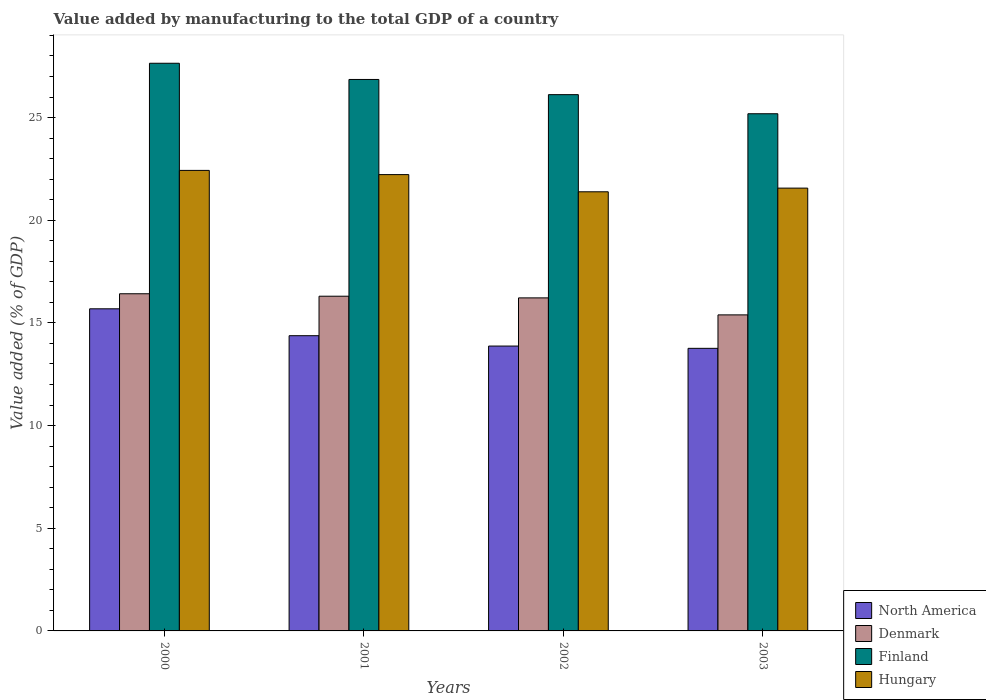How many different coloured bars are there?
Keep it short and to the point. 4. How many groups of bars are there?
Provide a short and direct response. 4. Are the number of bars on each tick of the X-axis equal?
Make the answer very short. Yes. How many bars are there on the 4th tick from the right?
Offer a terse response. 4. What is the label of the 3rd group of bars from the left?
Provide a succinct answer. 2002. What is the value added by manufacturing to the total GDP in North America in 2002?
Your answer should be compact. 13.87. Across all years, what is the maximum value added by manufacturing to the total GDP in Finland?
Your answer should be compact. 27.64. Across all years, what is the minimum value added by manufacturing to the total GDP in Denmark?
Your answer should be very brief. 15.39. In which year was the value added by manufacturing to the total GDP in Finland maximum?
Ensure brevity in your answer.  2000. In which year was the value added by manufacturing to the total GDP in Denmark minimum?
Keep it short and to the point. 2003. What is the total value added by manufacturing to the total GDP in Finland in the graph?
Your response must be concise. 105.8. What is the difference between the value added by manufacturing to the total GDP in North America in 2002 and that in 2003?
Give a very brief answer. 0.11. What is the difference between the value added by manufacturing to the total GDP in Finland in 2000 and the value added by manufacturing to the total GDP in North America in 2003?
Give a very brief answer. 13.88. What is the average value added by manufacturing to the total GDP in Denmark per year?
Offer a very short reply. 16.08. In the year 2003, what is the difference between the value added by manufacturing to the total GDP in Denmark and value added by manufacturing to the total GDP in North America?
Give a very brief answer. 1.63. What is the ratio of the value added by manufacturing to the total GDP in Denmark in 2001 to that in 2003?
Offer a very short reply. 1.06. What is the difference between the highest and the second highest value added by manufacturing to the total GDP in Hungary?
Make the answer very short. 0.2. What is the difference between the highest and the lowest value added by manufacturing to the total GDP in North America?
Keep it short and to the point. 1.92. In how many years, is the value added by manufacturing to the total GDP in Finland greater than the average value added by manufacturing to the total GDP in Finland taken over all years?
Give a very brief answer. 2. Is the sum of the value added by manufacturing to the total GDP in Denmark in 2000 and 2003 greater than the maximum value added by manufacturing to the total GDP in Finland across all years?
Offer a very short reply. Yes. What does the 4th bar from the right in 2003 represents?
Offer a terse response. North America. Is it the case that in every year, the sum of the value added by manufacturing to the total GDP in North America and value added by manufacturing to the total GDP in Denmark is greater than the value added by manufacturing to the total GDP in Hungary?
Ensure brevity in your answer.  Yes. How many bars are there?
Ensure brevity in your answer.  16. How many years are there in the graph?
Provide a short and direct response. 4. What is the difference between two consecutive major ticks on the Y-axis?
Your answer should be very brief. 5. Are the values on the major ticks of Y-axis written in scientific E-notation?
Offer a very short reply. No. Where does the legend appear in the graph?
Ensure brevity in your answer.  Bottom right. How are the legend labels stacked?
Provide a short and direct response. Vertical. What is the title of the graph?
Your response must be concise. Value added by manufacturing to the total GDP of a country. What is the label or title of the Y-axis?
Ensure brevity in your answer.  Value added (% of GDP). What is the Value added (% of GDP) of North America in 2000?
Your response must be concise. 15.69. What is the Value added (% of GDP) in Denmark in 2000?
Provide a short and direct response. 16.42. What is the Value added (% of GDP) in Finland in 2000?
Provide a short and direct response. 27.64. What is the Value added (% of GDP) of Hungary in 2000?
Provide a succinct answer. 22.43. What is the Value added (% of GDP) in North America in 2001?
Provide a short and direct response. 14.38. What is the Value added (% of GDP) of Denmark in 2001?
Make the answer very short. 16.3. What is the Value added (% of GDP) in Finland in 2001?
Your answer should be very brief. 26.85. What is the Value added (% of GDP) in Hungary in 2001?
Keep it short and to the point. 22.22. What is the Value added (% of GDP) of North America in 2002?
Your answer should be compact. 13.87. What is the Value added (% of GDP) in Denmark in 2002?
Give a very brief answer. 16.22. What is the Value added (% of GDP) of Finland in 2002?
Provide a short and direct response. 26.12. What is the Value added (% of GDP) of Hungary in 2002?
Make the answer very short. 21.38. What is the Value added (% of GDP) of North America in 2003?
Offer a very short reply. 13.76. What is the Value added (% of GDP) of Denmark in 2003?
Ensure brevity in your answer.  15.39. What is the Value added (% of GDP) of Finland in 2003?
Provide a short and direct response. 25.18. What is the Value added (% of GDP) in Hungary in 2003?
Offer a terse response. 21.56. Across all years, what is the maximum Value added (% of GDP) of North America?
Make the answer very short. 15.69. Across all years, what is the maximum Value added (% of GDP) in Denmark?
Ensure brevity in your answer.  16.42. Across all years, what is the maximum Value added (% of GDP) of Finland?
Give a very brief answer. 27.64. Across all years, what is the maximum Value added (% of GDP) in Hungary?
Your answer should be compact. 22.43. Across all years, what is the minimum Value added (% of GDP) of North America?
Your answer should be compact. 13.76. Across all years, what is the minimum Value added (% of GDP) in Denmark?
Offer a very short reply. 15.39. Across all years, what is the minimum Value added (% of GDP) of Finland?
Your answer should be very brief. 25.18. Across all years, what is the minimum Value added (% of GDP) of Hungary?
Provide a succinct answer. 21.38. What is the total Value added (% of GDP) of North America in the graph?
Ensure brevity in your answer.  57.7. What is the total Value added (% of GDP) in Denmark in the graph?
Your answer should be very brief. 64.33. What is the total Value added (% of GDP) in Finland in the graph?
Make the answer very short. 105.8. What is the total Value added (% of GDP) of Hungary in the graph?
Your answer should be very brief. 87.59. What is the difference between the Value added (% of GDP) of North America in 2000 and that in 2001?
Your answer should be compact. 1.31. What is the difference between the Value added (% of GDP) in Denmark in 2000 and that in 2001?
Your answer should be very brief. 0.12. What is the difference between the Value added (% of GDP) in Finland in 2000 and that in 2001?
Give a very brief answer. 0.79. What is the difference between the Value added (% of GDP) in Hungary in 2000 and that in 2001?
Make the answer very short. 0.2. What is the difference between the Value added (% of GDP) of North America in 2000 and that in 2002?
Make the answer very short. 1.81. What is the difference between the Value added (% of GDP) in Denmark in 2000 and that in 2002?
Your response must be concise. 0.2. What is the difference between the Value added (% of GDP) of Finland in 2000 and that in 2002?
Offer a terse response. 1.53. What is the difference between the Value added (% of GDP) of Hungary in 2000 and that in 2002?
Give a very brief answer. 1.04. What is the difference between the Value added (% of GDP) of North America in 2000 and that in 2003?
Provide a short and direct response. 1.92. What is the difference between the Value added (% of GDP) of Denmark in 2000 and that in 2003?
Your answer should be compact. 1.03. What is the difference between the Value added (% of GDP) of Finland in 2000 and that in 2003?
Give a very brief answer. 2.46. What is the difference between the Value added (% of GDP) of Hungary in 2000 and that in 2003?
Your answer should be compact. 0.86. What is the difference between the Value added (% of GDP) in North America in 2001 and that in 2002?
Provide a succinct answer. 0.5. What is the difference between the Value added (% of GDP) in Denmark in 2001 and that in 2002?
Your answer should be compact. 0.08. What is the difference between the Value added (% of GDP) in Finland in 2001 and that in 2002?
Provide a short and direct response. 0.74. What is the difference between the Value added (% of GDP) of Hungary in 2001 and that in 2002?
Your answer should be compact. 0.84. What is the difference between the Value added (% of GDP) of North America in 2001 and that in 2003?
Your response must be concise. 0.62. What is the difference between the Value added (% of GDP) in Denmark in 2001 and that in 2003?
Offer a very short reply. 0.91. What is the difference between the Value added (% of GDP) in Finland in 2001 and that in 2003?
Your response must be concise. 1.67. What is the difference between the Value added (% of GDP) in Hungary in 2001 and that in 2003?
Offer a terse response. 0.66. What is the difference between the Value added (% of GDP) of Denmark in 2002 and that in 2003?
Keep it short and to the point. 0.83. What is the difference between the Value added (% of GDP) in Finland in 2002 and that in 2003?
Offer a terse response. 0.93. What is the difference between the Value added (% of GDP) of Hungary in 2002 and that in 2003?
Keep it short and to the point. -0.18. What is the difference between the Value added (% of GDP) in North America in 2000 and the Value added (% of GDP) in Denmark in 2001?
Your answer should be very brief. -0.61. What is the difference between the Value added (% of GDP) in North America in 2000 and the Value added (% of GDP) in Finland in 2001?
Provide a short and direct response. -11.17. What is the difference between the Value added (% of GDP) in North America in 2000 and the Value added (% of GDP) in Hungary in 2001?
Your answer should be compact. -6.54. What is the difference between the Value added (% of GDP) in Denmark in 2000 and the Value added (% of GDP) in Finland in 2001?
Provide a short and direct response. -10.44. What is the difference between the Value added (% of GDP) of Denmark in 2000 and the Value added (% of GDP) of Hungary in 2001?
Your answer should be very brief. -5.8. What is the difference between the Value added (% of GDP) of Finland in 2000 and the Value added (% of GDP) of Hungary in 2001?
Keep it short and to the point. 5.42. What is the difference between the Value added (% of GDP) of North America in 2000 and the Value added (% of GDP) of Denmark in 2002?
Your answer should be compact. -0.53. What is the difference between the Value added (% of GDP) of North America in 2000 and the Value added (% of GDP) of Finland in 2002?
Offer a terse response. -10.43. What is the difference between the Value added (% of GDP) in North America in 2000 and the Value added (% of GDP) in Hungary in 2002?
Your answer should be very brief. -5.7. What is the difference between the Value added (% of GDP) in Denmark in 2000 and the Value added (% of GDP) in Finland in 2002?
Ensure brevity in your answer.  -9.7. What is the difference between the Value added (% of GDP) in Denmark in 2000 and the Value added (% of GDP) in Hungary in 2002?
Make the answer very short. -4.97. What is the difference between the Value added (% of GDP) in Finland in 2000 and the Value added (% of GDP) in Hungary in 2002?
Your answer should be very brief. 6.26. What is the difference between the Value added (% of GDP) in North America in 2000 and the Value added (% of GDP) in Denmark in 2003?
Provide a succinct answer. 0.3. What is the difference between the Value added (% of GDP) of North America in 2000 and the Value added (% of GDP) of Finland in 2003?
Provide a short and direct response. -9.5. What is the difference between the Value added (% of GDP) in North America in 2000 and the Value added (% of GDP) in Hungary in 2003?
Provide a succinct answer. -5.88. What is the difference between the Value added (% of GDP) of Denmark in 2000 and the Value added (% of GDP) of Finland in 2003?
Your response must be concise. -8.77. What is the difference between the Value added (% of GDP) of Denmark in 2000 and the Value added (% of GDP) of Hungary in 2003?
Ensure brevity in your answer.  -5.14. What is the difference between the Value added (% of GDP) of Finland in 2000 and the Value added (% of GDP) of Hungary in 2003?
Your answer should be very brief. 6.08. What is the difference between the Value added (% of GDP) of North America in 2001 and the Value added (% of GDP) of Denmark in 2002?
Your answer should be very brief. -1.84. What is the difference between the Value added (% of GDP) of North America in 2001 and the Value added (% of GDP) of Finland in 2002?
Provide a succinct answer. -11.74. What is the difference between the Value added (% of GDP) in North America in 2001 and the Value added (% of GDP) in Hungary in 2002?
Your answer should be very brief. -7.01. What is the difference between the Value added (% of GDP) in Denmark in 2001 and the Value added (% of GDP) in Finland in 2002?
Provide a succinct answer. -9.82. What is the difference between the Value added (% of GDP) of Denmark in 2001 and the Value added (% of GDP) of Hungary in 2002?
Your answer should be compact. -5.08. What is the difference between the Value added (% of GDP) of Finland in 2001 and the Value added (% of GDP) of Hungary in 2002?
Provide a succinct answer. 5.47. What is the difference between the Value added (% of GDP) of North America in 2001 and the Value added (% of GDP) of Denmark in 2003?
Keep it short and to the point. -1.01. What is the difference between the Value added (% of GDP) of North America in 2001 and the Value added (% of GDP) of Finland in 2003?
Offer a very short reply. -10.81. What is the difference between the Value added (% of GDP) of North America in 2001 and the Value added (% of GDP) of Hungary in 2003?
Make the answer very short. -7.19. What is the difference between the Value added (% of GDP) in Denmark in 2001 and the Value added (% of GDP) in Finland in 2003?
Provide a short and direct response. -8.89. What is the difference between the Value added (% of GDP) of Denmark in 2001 and the Value added (% of GDP) of Hungary in 2003?
Offer a very short reply. -5.26. What is the difference between the Value added (% of GDP) of Finland in 2001 and the Value added (% of GDP) of Hungary in 2003?
Make the answer very short. 5.29. What is the difference between the Value added (% of GDP) of North America in 2002 and the Value added (% of GDP) of Denmark in 2003?
Offer a terse response. -1.52. What is the difference between the Value added (% of GDP) of North America in 2002 and the Value added (% of GDP) of Finland in 2003?
Provide a succinct answer. -11.31. What is the difference between the Value added (% of GDP) of North America in 2002 and the Value added (% of GDP) of Hungary in 2003?
Your answer should be compact. -7.69. What is the difference between the Value added (% of GDP) in Denmark in 2002 and the Value added (% of GDP) in Finland in 2003?
Ensure brevity in your answer.  -8.97. What is the difference between the Value added (% of GDP) in Denmark in 2002 and the Value added (% of GDP) in Hungary in 2003?
Provide a short and direct response. -5.35. What is the difference between the Value added (% of GDP) in Finland in 2002 and the Value added (% of GDP) in Hungary in 2003?
Your response must be concise. 4.55. What is the average Value added (% of GDP) in North America per year?
Offer a very short reply. 14.42. What is the average Value added (% of GDP) of Denmark per year?
Offer a terse response. 16.08. What is the average Value added (% of GDP) of Finland per year?
Your answer should be compact. 26.45. What is the average Value added (% of GDP) in Hungary per year?
Your response must be concise. 21.9. In the year 2000, what is the difference between the Value added (% of GDP) in North America and Value added (% of GDP) in Denmark?
Make the answer very short. -0.73. In the year 2000, what is the difference between the Value added (% of GDP) in North America and Value added (% of GDP) in Finland?
Provide a short and direct response. -11.96. In the year 2000, what is the difference between the Value added (% of GDP) in North America and Value added (% of GDP) in Hungary?
Offer a terse response. -6.74. In the year 2000, what is the difference between the Value added (% of GDP) in Denmark and Value added (% of GDP) in Finland?
Provide a succinct answer. -11.22. In the year 2000, what is the difference between the Value added (% of GDP) in Denmark and Value added (% of GDP) in Hungary?
Provide a short and direct response. -6.01. In the year 2000, what is the difference between the Value added (% of GDP) of Finland and Value added (% of GDP) of Hungary?
Your response must be concise. 5.22. In the year 2001, what is the difference between the Value added (% of GDP) in North America and Value added (% of GDP) in Denmark?
Ensure brevity in your answer.  -1.92. In the year 2001, what is the difference between the Value added (% of GDP) of North America and Value added (% of GDP) of Finland?
Your answer should be compact. -12.48. In the year 2001, what is the difference between the Value added (% of GDP) in North America and Value added (% of GDP) in Hungary?
Provide a succinct answer. -7.84. In the year 2001, what is the difference between the Value added (% of GDP) of Denmark and Value added (% of GDP) of Finland?
Your answer should be compact. -10.56. In the year 2001, what is the difference between the Value added (% of GDP) of Denmark and Value added (% of GDP) of Hungary?
Give a very brief answer. -5.92. In the year 2001, what is the difference between the Value added (% of GDP) in Finland and Value added (% of GDP) in Hungary?
Give a very brief answer. 4.63. In the year 2002, what is the difference between the Value added (% of GDP) of North America and Value added (% of GDP) of Denmark?
Your response must be concise. -2.35. In the year 2002, what is the difference between the Value added (% of GDP) in North America and Value added (% of GDP) in Finland?
Ensure brevity in your answer.  -12.24. In the year 2002, what is the difference between the Value added (% of GDP) of North America and Value added (% of GDP) of Hungary?
Ensure brevity in your answer.  -7.51. In the year 2002, what is the difference between the Value added (% of GDP) in Denmark and Value added (% of GDP) in Finland?
Provide a succinct answer. -9.9. In the year 2002, what is the difference between the Value added (% of GDP) of Denmark and Value added (% of GDP) of Hungary?
Your answer should be compact. -5.17. In the year 2002, what is the difference between the Value added (% of GDP) of Finland and Value added (% of GDP) of Hungary?
Your response must be concise. 4.73. In the year 2003, what is the difference between the Value added (% of GDP) of North America and Value added (% of GDP) of Denmark?
Provide a short and direct response. -1.63. In the year 2003, what is the difference between the Value added (% of GDP) of North America and Value added (% of GDP) of Finland?
Your response must be concise. -11.42. In the year 2003, what is the difference between the Value added (% of GDP) in North America and Value added (% of GDP) in Hungary?
Offer a terse response. -7.8. In the year 2003, what is the difference between the Value added (% of GDP) of Denmark and Value added (% of GDP) of Finland?
Your answer should be very brief. -9.79. In the year 2003, what is the difference between the Value added (% of GDP) in Denmark and Value added (% of GDP) in Hungary?
Offer a very short reply. -6.17. In the year 2003, what is the difference between the Value added (% of GDP) of Finland and Value added (% of GDP) of Hungary?
Offer a terse response. 3.62. What is the ratio of the Value added (% of GDP) of North America in 2000 to that in 2001?
Provide a short and direct response. 1.09. What is the ratio of the Value added (% of GDP) of Denmark in 2000 to that in 2001?
Provide a short and direct response. 1.01. What is the ratio of the Value added (% of GDP) of Finland in 2000 to that in 2001?
Your response must be concise. 1.03. What is the ratio of the Value added (% of GDP) in Hungary in 2000 to that in 2001?
Offer a very short reply. 1.01. What is the ratio of the Value added (% of GDP) of North America in 2000 to that in 2002?
Ensure brevity in your answer.  1.13. What is the ratio of the Value added (% of GDP) of Denmark in 2000 to that in 2002?
Your answer should be compact. 1.01. What is the ratio of the Value added (% of GDP) in Finland in 2000 to that in 2002?
Offer a very short reply. 1.06. What is the ratio of the Value added (% of GDP) of Hungary in 2000 to that in 2002?
Give a very brief answer. 1.05. What is the ratio of the Value added (% of GDP) in North America in 2000 to that in 2003?
Keep it short and to the point. 1.14. What is the ratio of the Value added (% of GDP) in Denmark in 2000 to that in 2003?
Offer a terse response. 1.07. What is the ratio of the Value added (% of GDP) in Finland in 2000 to that in 2003?
Keep it short and to the point. 1.1. What is the ratio of the Value added (% of GDP) of North America in 2001 to that in 2002?
Your answer should be compact. 1.04. What is the ratio of the Value added (% of GDP) in Denmark in 2001 to that in 2002?
Ensure brevity in your answer.  1. What is the ratio of the Value added (% of GDP) of Finland in 2001 to that in 2002?
Your answer should be very brief. 1.03. What is the ratio of the Value added (% of GDP) of Hungary in 2001 to that in 2002?
Offer a terse response. 1.04. What is the ratio of the Value added (% of GDP) in North America in 2001 to that in 2003?
Your answer should be compact. 1.04. What is the ratio of the Value added (% of GDP) of Denmark in 2001 to that in 2003?
Make the answer very short. 1.06. What is the ratio of the Value added (% of GDP) of Finland in 2001 to that in 2003?
Offer a very short reply. 1.07. What is the ratio of the Value added (% of GDP) in Hungary in 2001 to that in 2003?
Your response must be concise. 1.03. What is the ratio of the Value added (% of GDP) in Denmark in 2002 to that in 2003?
Offer a terse response. 1.05. What is the ratio of the Value added (% of GDP) of Finland in 2002 to that in 2003?
Offer a terse response. 1.04. What is the difference between the highest and the second highest Value added (% of GDP) of North America?
Offer a terse response. 1.31. What is the difference between the highest and the second highest Value added (% of GDP) in Denmark?
Give a very brief answer. 0.12. What is the difference between the highest and the second highest Value added (% of GDP) of Finland?
Provide a succinct answer. 0.79. What is the difference between the highest and the second highest Value added (% of GDP) of Hungary?
Provide a short and direct response. 0.2. What is the difference between the highest and the lowest Value added (% of GDP) in North America?
Your answer should be compact. 1.92. What is the difference between the highest and the lowest Value added (% of GDP) in Denmark?
Give a very brief answer. 1.03. What is the difference between the highest and the lowest Value added (% of GDP) in Finland?
Give a very brief answer. 2.46. What is the difference between the highest and the lowest Value added (% of GDP) of Hungary?
Offer a very short reply. 1.04. 